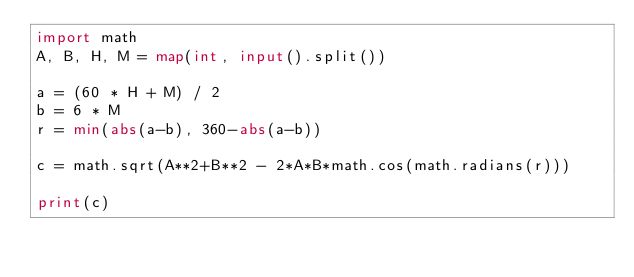<code> <loc_0><loc_0><loc_500><loc_500><_Python_>import math
A, B, H, M = map(int, input().split())

a = (60 * H + M) / 2
b = 6 * M
r = min(abs(a-b), 360-abs(a-b))

c = math.sqrt(A**2+B**2 - 2*A*B*math.cos(math.radians(r)))

print(c)</code> 